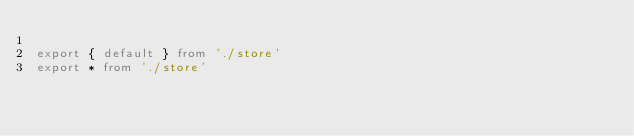<code> <loc_0><loc_0><loc_500><loc_500><_TypeScript_>
export { default } from './store'
export * from './store'
</code> 